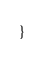Convert code to text. <code><loc_0><loc_0><loc_500><loc_500><_Scala_>}
</code> 